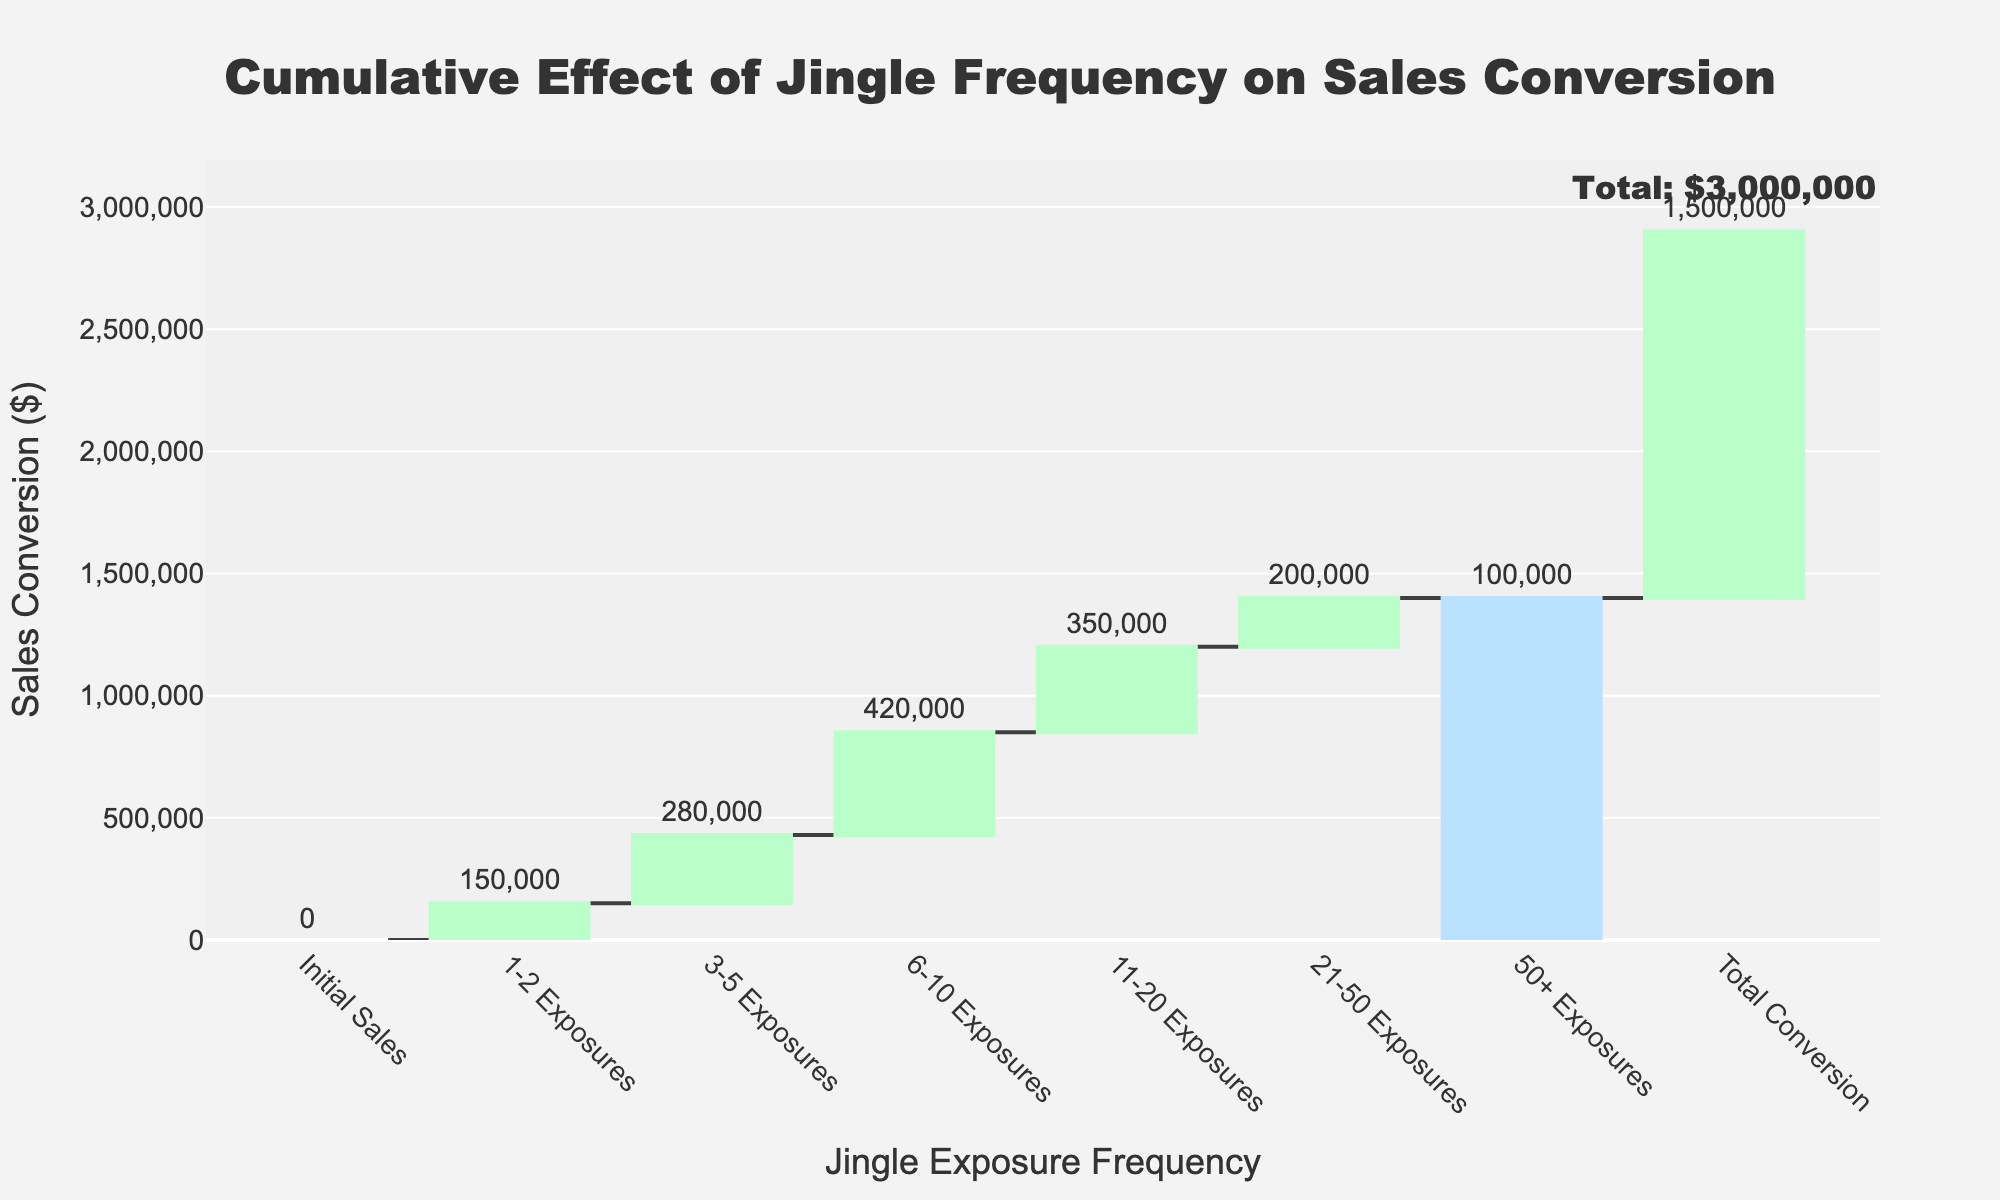What's the title of the chart? The title is written at the top center of the chart in a large font. It indicates the main subject of the figure.
Answer: Cumulative Effect of Jingle Frequency on Sales Conversion Which exposure category has the highest sales conversion? By examining the bars, the tallest bar represents the 6-10 Exposures category.
Answer: 6-10 Exposures What is the total sales conversion amount? The total is annotated at the end of the chart and also represented by the total bar.
Answer: $1,500,000 How much do sales conversion increase from 3-5 Exposures to 6-10 Exposures? Subtract the value of the 3-5 Exposures from the 6-10 Exposures. 420,000 - 280,000 = 140,000.
Answer: $140,000 Which category contributes the least to the total sales conversion? By comparing the heights of the bars, the shortest bar corresponds to the 50+ Exposures category.
Answer: 50+ Exposures What is the combined total sales conversion from 1-2 Exposures and 3-5 Exposures? Add the values from both categories together. 150,000 + 280,000 = 430,000.
Answer: $430,000 How many categories are listed in the chart excluding the total? Count the number of distinct categories before the 'Total Conversion'.
Answer: 6 What is the range of sales conversion values (lowest to highest) in the chart? The range is the difference between the highest and lowest sales conversion values. 420,000 (highest) - 100,000 (lowest).
Answer: $320,000 Do sales conversions decrease after the 6-10 Exposures category? Yes, by observing the subsequent bars, the sales conversion decreases after the peak in the 6-10 Exposures category.
Answer: Yes 